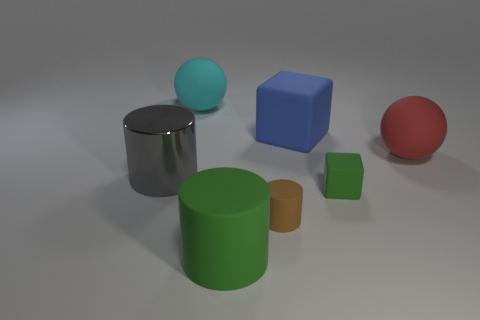The green thing on the right side of the large cylinder to the right of the gray cylinder is made of what material?
Keep it short and to the point. Rubber. There is another object that is the same shape as the big red object; what size is it?
Provide a succinct answer. Large. Is the color of the metal cylinder the same as the tiny matte cube?
Offer a very short reply. No. What is the color of the big matte object that is both in front of the big block and left of the small matte cube?
Provide a succinct answer. Green. Do the ball that is in front of the blue matte object and the big gray object have the same size?
Give a very brief answer. Yes. Is there anything else that is the same shape as the big cyan rubber thing?
Make the answer very short. Yes. Is the small green object made of the same material as the big cylinder behind the green cylinder?
Make the answer very short. No. What number of brown things are either rubber blocks or balls?
Ensure brevity in your answer.  0. Are any tiny gray shiny blocks visible?
Provide a succinct answer. No. Is there a tiny matte thing that is behind the big ball to the right of the large ball left of the blue rubber cube?
Ensure brevity in your answer.  No. 